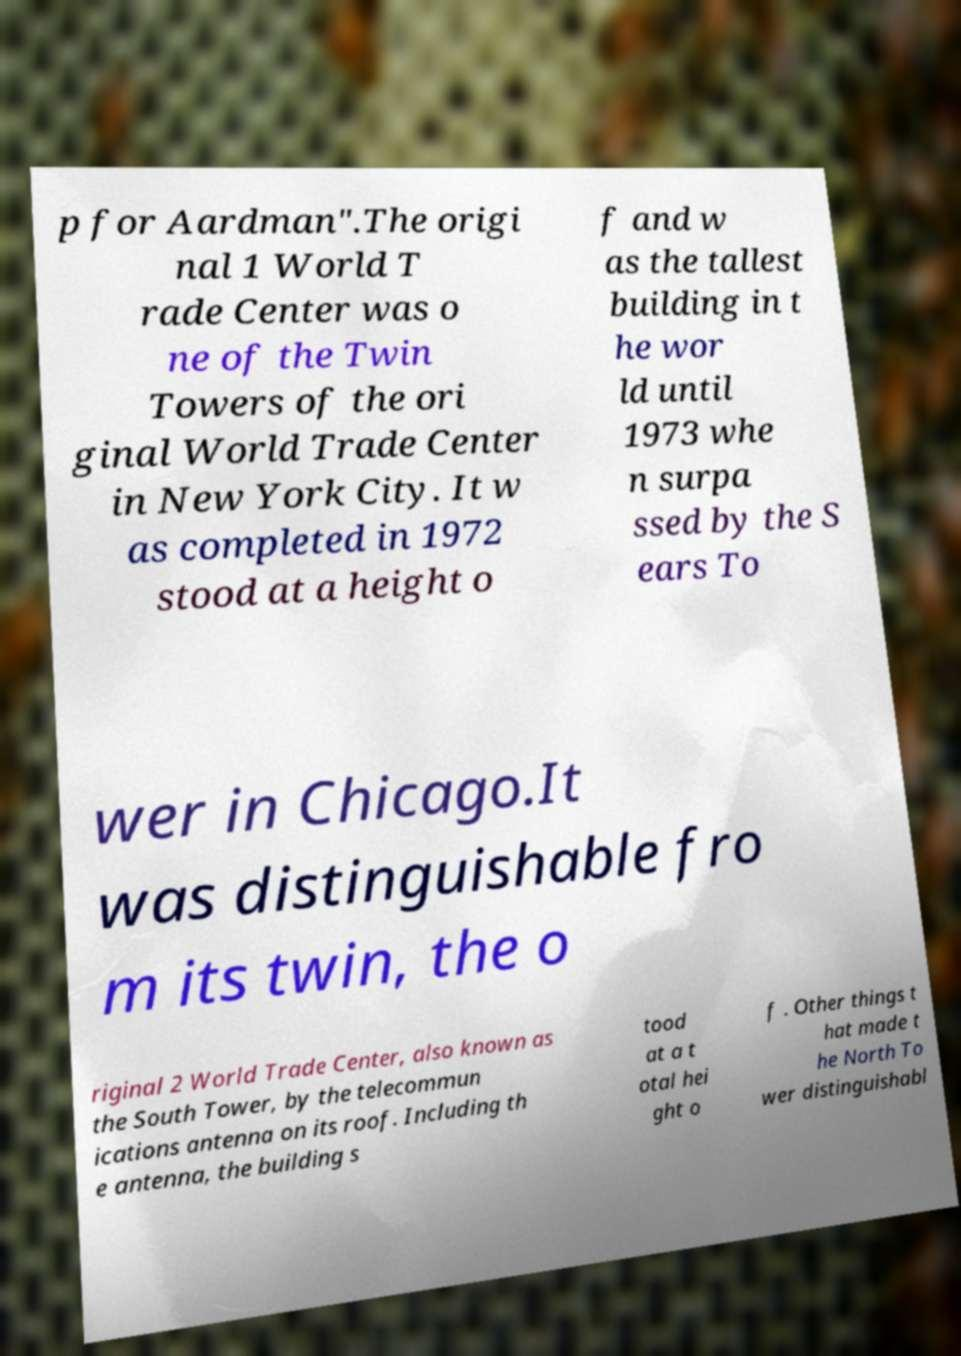For documentation purposes, I need the text within this image transcribed. Could you provide that? p for Aardman".The origi nal 1 World T rade Center was o ne of the Twin Towers of the ori ginal World Trade Center in New York City. It w as completed in 1972 stood at a height o f and w as the tallest building in t he wor ld until 1973 whe n surpa ssed by the S ears To wer in Chicago.It was distinguishable fro m its twin, the o riginal 2 World Trade Center, also known as the South Tower, by the telecommun ications antenna on its roof. Including th e antenna, the building s tood at a t otal hei ght o f . Other things t hat made t he North To wer distinguishabl 